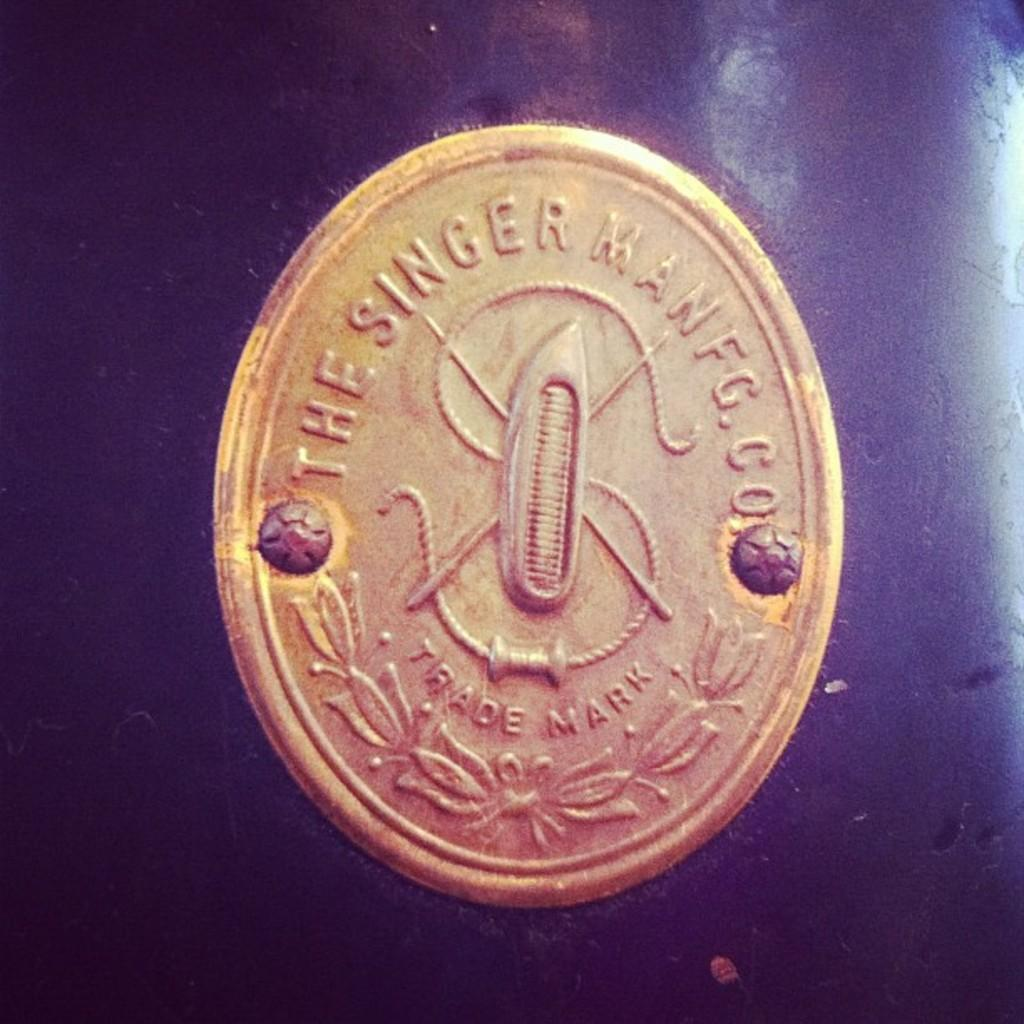Provide a one-sentence caption for the provided image. a golden coin that says 'the singer man fg.co'. 